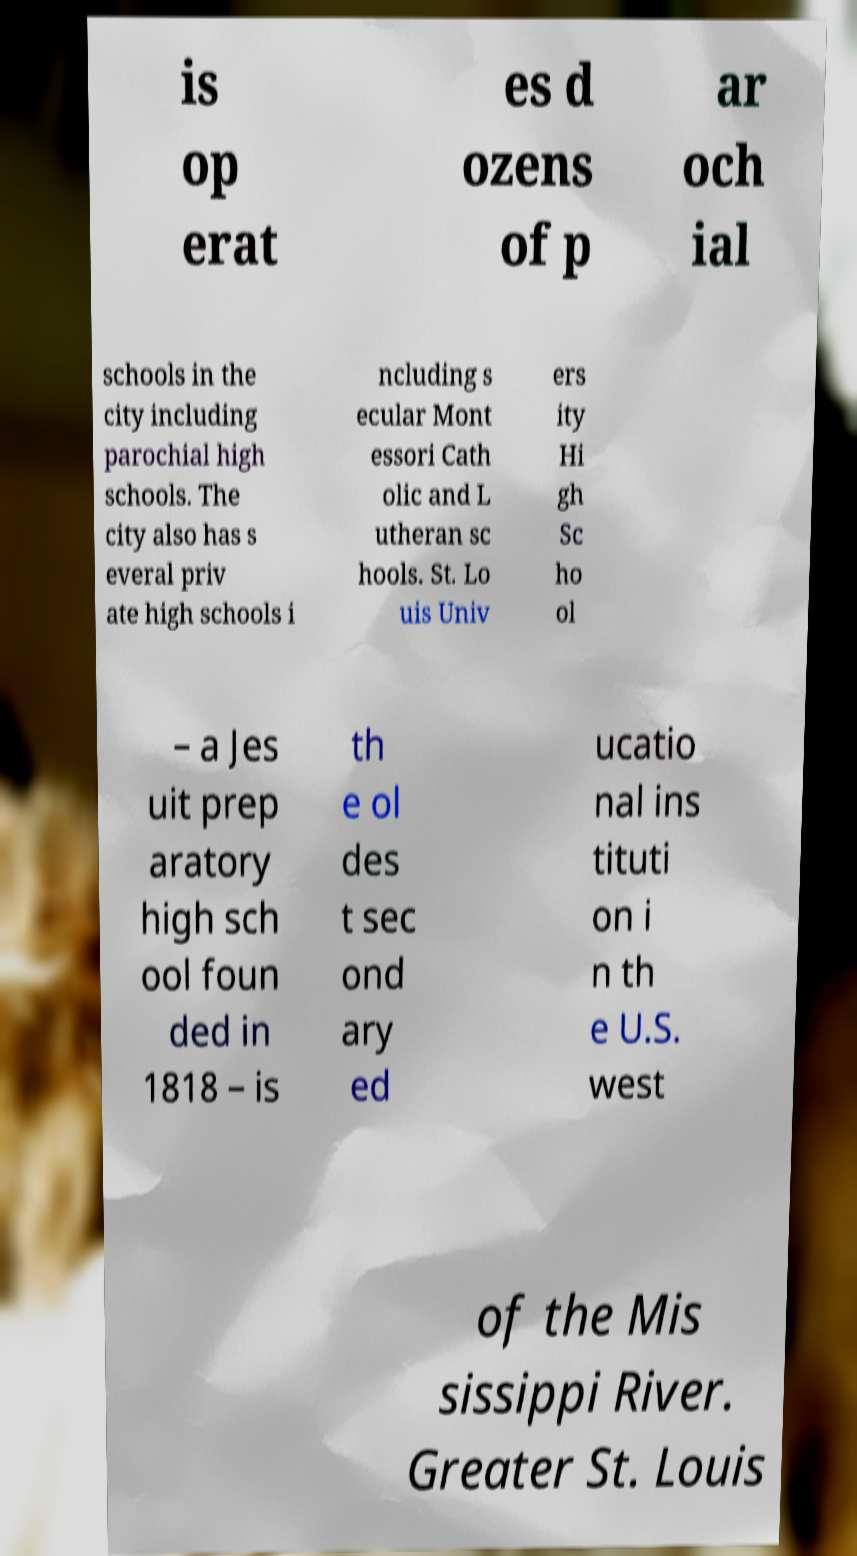Please read and relay the text visible in this image. What does it say? is op erat es d ozens of p ar och ial schools in the city including parochial high schools. The city also has s everal priv ate high schools i ncluding s ecular Mont essori Cath olic and L utheran sc hools. St. Lo uis Univ ers ity Hi gh Sc ho ol – a Jes uit prep aratory high sch ool foun ded in 1818 – is th e ol des t sec ond ary ed ucatio nal ins tituti on i n th e U.S. west of the Mis sissippi River. Greater St. Louis 